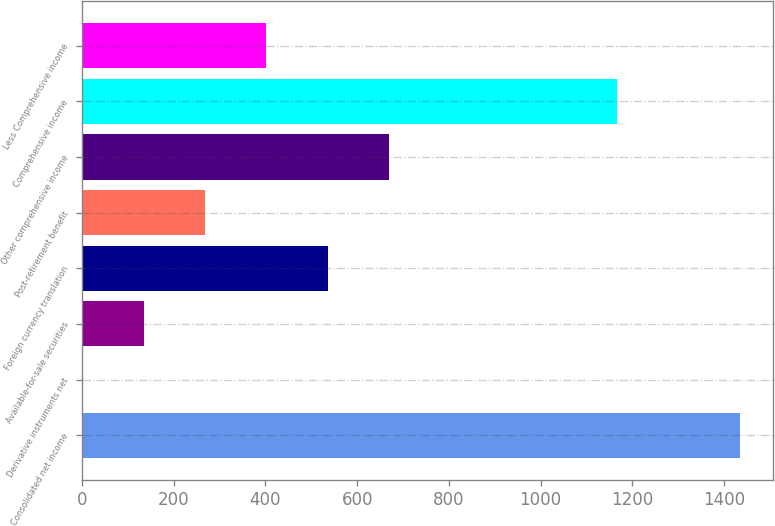Convert chart. <chart><loc_0><loc_0><loc_500><loc_500><bar_chart><fcel>Consolidated net income<fcel>Derivative instruments net<fcel>Available-for-sale securities<fcel>Foreign currency translation<fcel>Post-retirement benefit<fcel>Other comprehensive income<fcel>Comprehensive income<fcel>Less Comprehensive income<nl><fcel>1434.4<fcel>1<fcel>134.7<fcel>535.8<fcel>268.4<fcel>669.5<fcel>1167<fcel>402.1<nl></chart> 